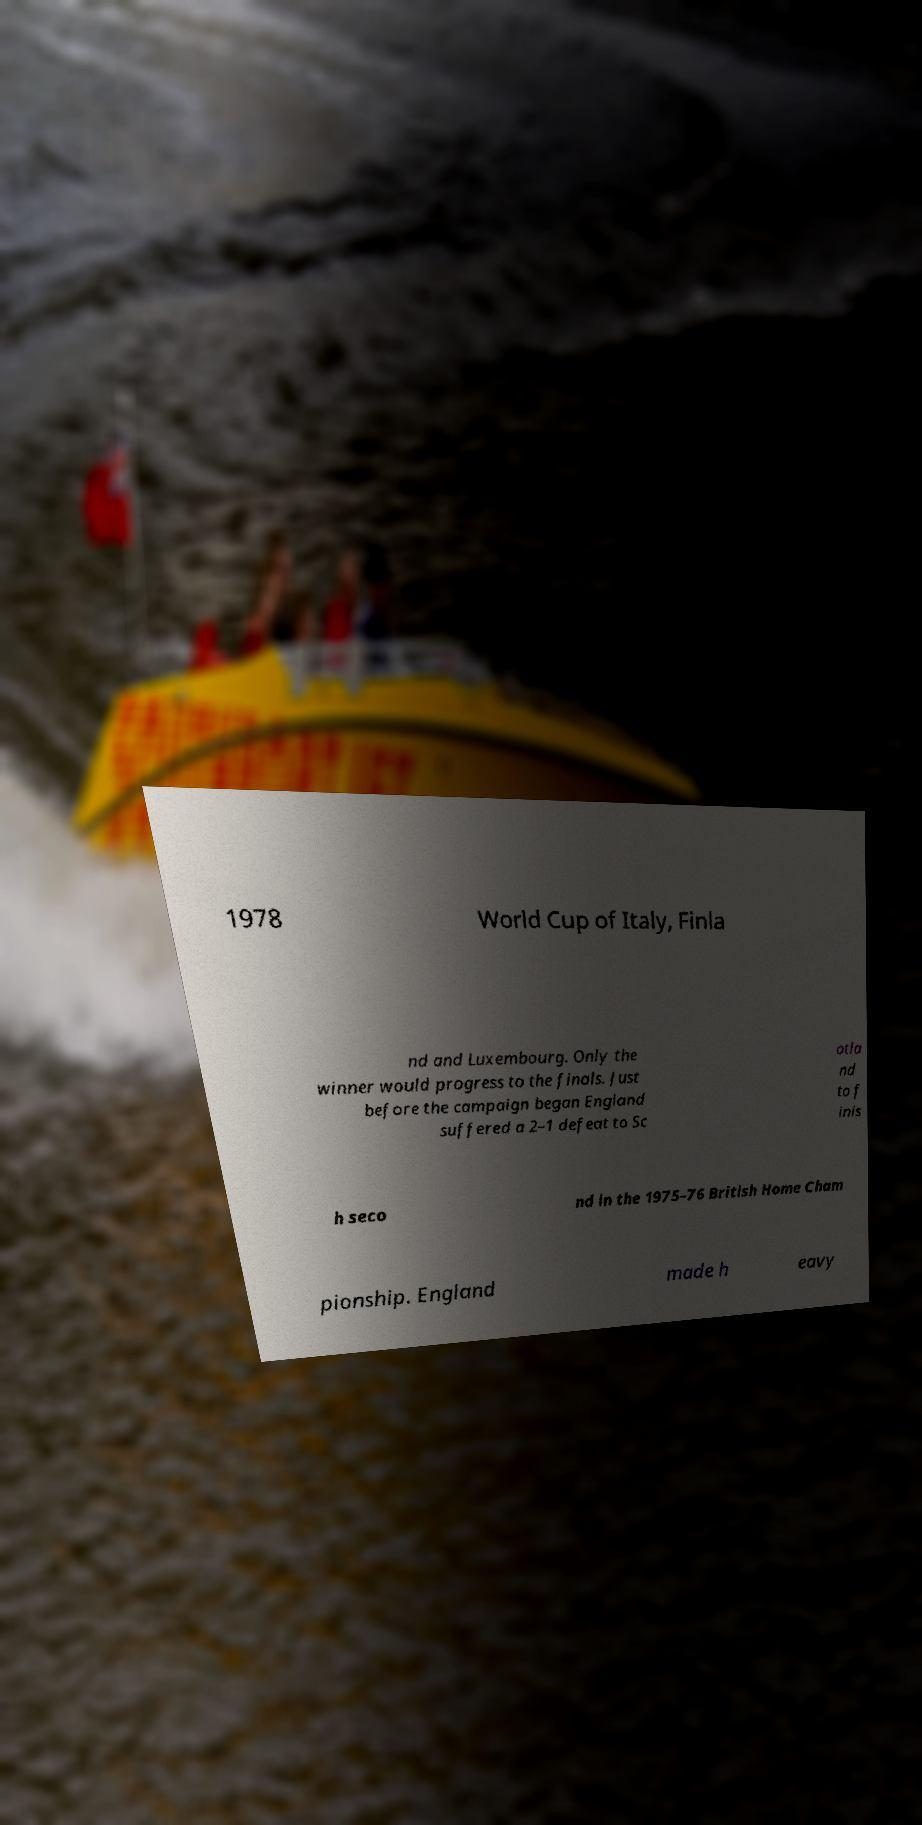Can you read and provide the text displayed in the image?This photo seems to have some interesting text. Can you extract and type it out for me? 1978 World Cup of Italy, Finla nd and Luxembourg. Only the winner would progress to the finals. Just before the campaign began England suffered a 2–1 defeat to Sc otla nd to f inis h seco nd in the 1975–76 British Home Cham pionship. England made h eavy 